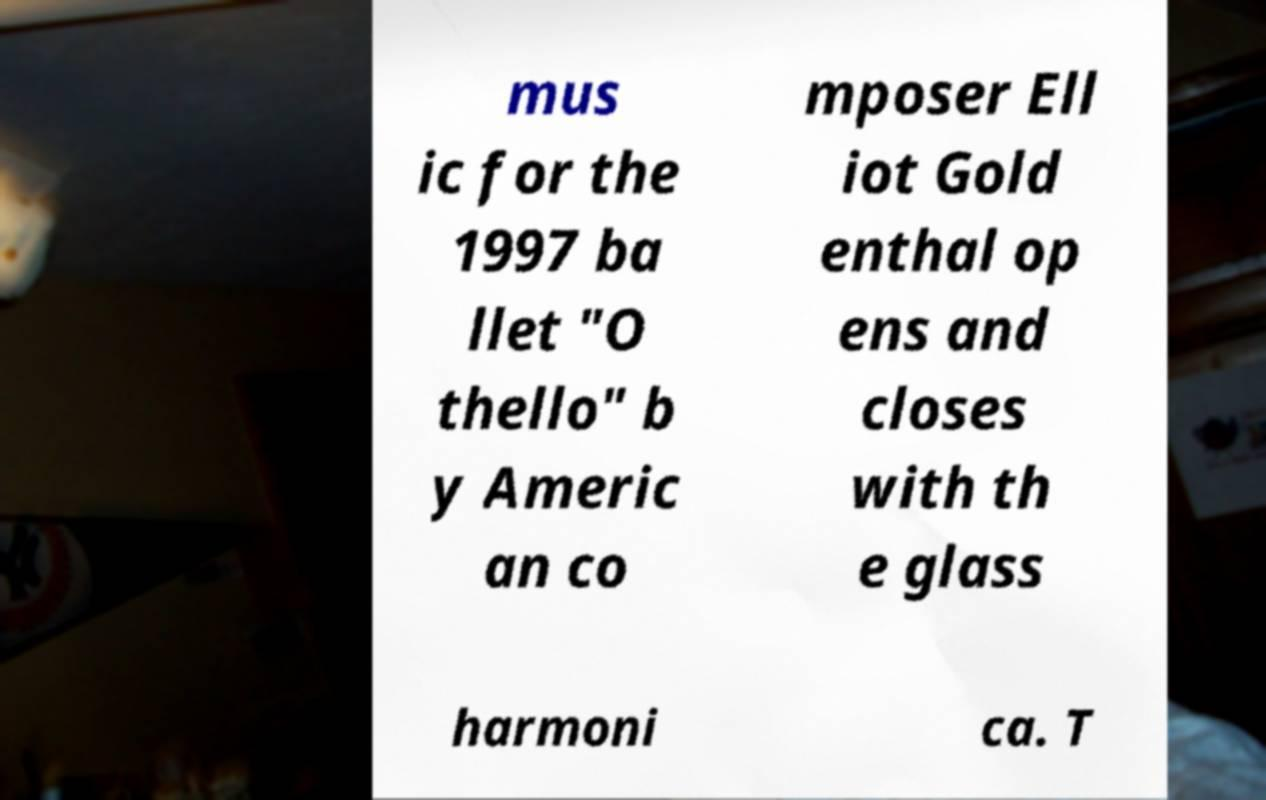What messages or text are displayed in this image? I need them in a readable, typed format. mus ic for the 1997 ba llet "O thello" b y Americ an co mposer Ell iot Gold enthal op ens and closes with th e glass harmoni ca. T 